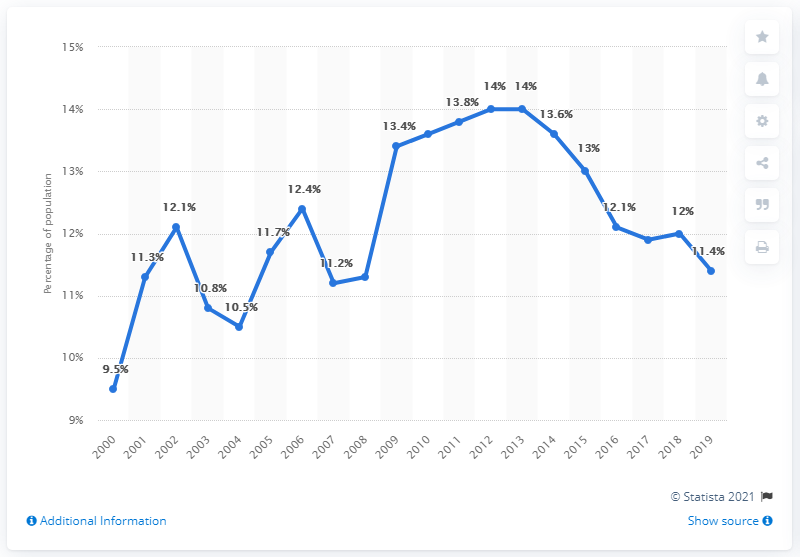Draw attention to some important aspects in this diagram. The value of the blue line chart in 2009 was 13.4. The average score over the last five years is 12.42. 